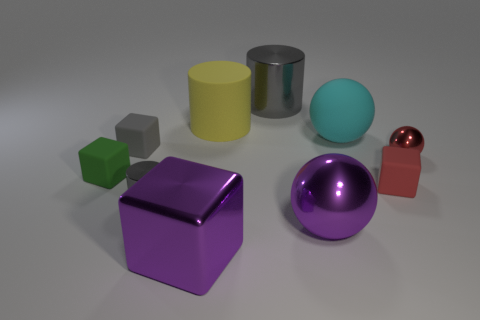Subtract all purple metal blocks. How many blocks are left? 3 Subtract all purple balls. How many gray cylinders are left? 2 Subtract all purple blocks. How many blocks are left? 3 Subtract 3 blocks. How many blocks are left? 1 Subtract all balls. How many objects are left? 7 Subtract all brown cylinders. Subtract all cyan blocks. How many cylinders are left? 3 Subtract all tiny red metallic things. Subtract all large yellow matte objects. How many objects are left? 8 Add 7 large spheres. How many large spheres are left? 9 Add 4 large purple balls. How many large purple balls exist? 5 Subtract 1 yellow cylinders. How many objects are left? 9 